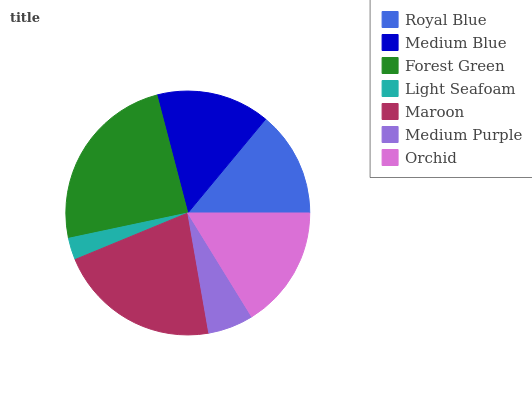Is Light Seafoam the minimum?
Answer yes or no. Yes. Is Forest Green the maximum?
Answer yes or no. Yes. Is Medium Blue the minimum?
Answer yes or no. No. Is Medium Blue the maximum?
Answer yes or no. No. Is Medium Blue greater than Royal Blue?
Answer yes or no. Yes. Is Royal Blue less than Medium Blue?
Answer yes or no. Yes. Is Royal Blue greater than Medium Blue?
Answer yes or no. No. Is Medium Blue less than Royal Blue?
Answer yes or no. No. Is Medium Blue the high median?
Answer yes or no. Yes. Is Medium Blue the low median?
Answer yes or no. Yes. Is Medium Purple the high median?
Answer yes or no. No. Is Royal Blue the low median?
Answer yes or no. No. 